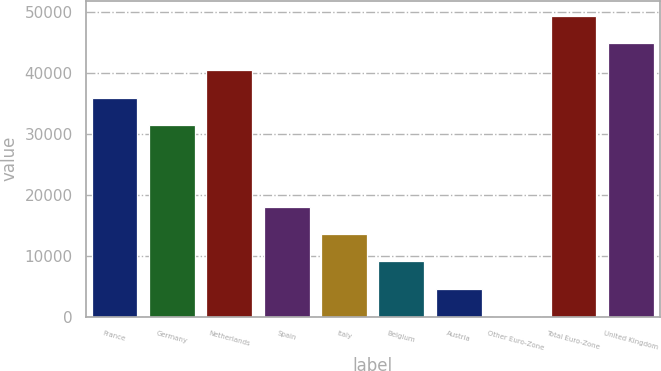Convert chart. <chart><loc_0><loc_0><loc_500><loc_500><bar_chart><fcel>France<fcel>Germany<fcel>Netherlands<fcel>Spain<fcel>Italy<fcel>Belgium<fcel>Austria<fcel>Other Euro-Zone<fcel>Total Euro-Zone<fcel>United Kingdom<nl><fcel>35899.2<fcel>31429.3<fcel>40369.1<fcel>18019.6<fcel>13549.7<fcel>9079.8<fcel>4609.9<fcel>140<fcel>49308.9<fcel>44839<nl></chart> 